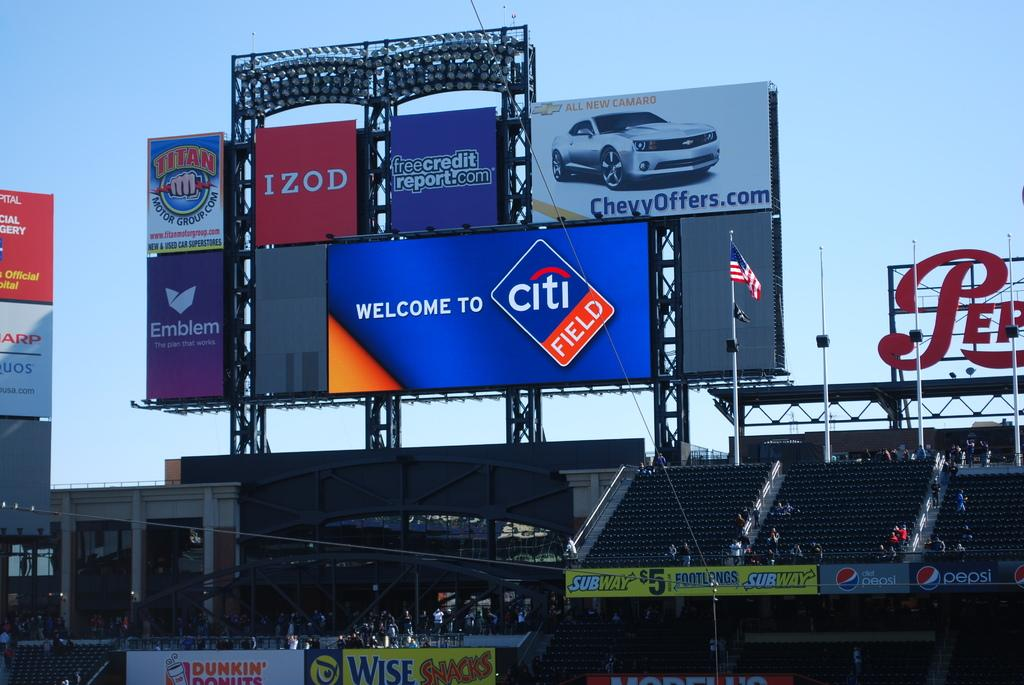<image>
Offer a succinct explanation of the picture presented. The inside of a baseball arena showing advertising for Izod and freecreditreport.com. 